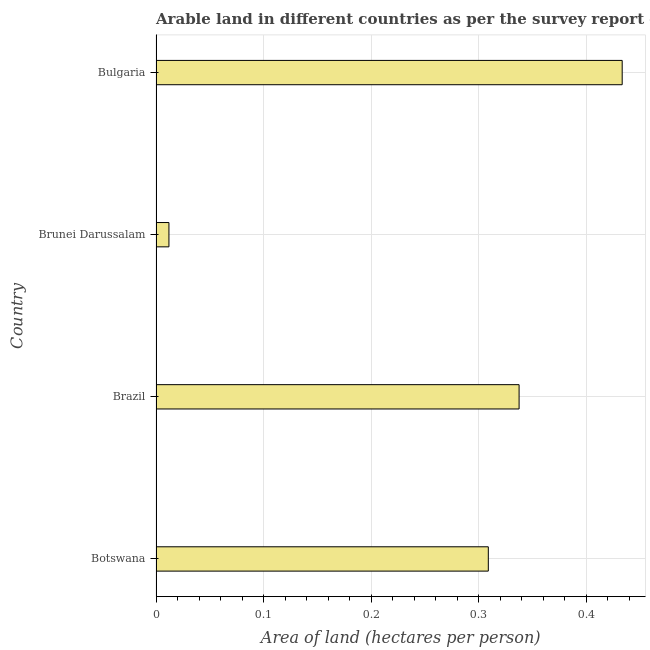What is the title of the graph?
Keep it short and to the point. Arable land in different countries as per the survey report of the year 1989. What is the label or title of the X-axis?
Offer a very short reply. Area of land (hectares per person). What is the label or title of the Y-axis?
Make the answer very short. Country. What is the area of arable land in Brunei Darussalam?
Offer a very short reply. 0.01. Across all countries, what is the maximum area of arable land?
Provide a succinct answer. 0.43. Across all countries, what is the minimum area of arable land?
Give a very brief answer. 0.01. In which country was the area of arable land maximum?
Your response must be concise. Bulgaria. In which country was the area of arable land minimum?
Provide a succinct answer. Brunei Darussalam. What is the sum of the area of arable land?
Your answer should be compact. 1.09. What is the difference between the area of arable land in Brazil and Brunei Darussalam?
Keep it short and to the point. 0.33. What is the average area of arable land per country?
Ensure brevity in your answer.  0.27. What is the median area of arable land?
Your answer should be very brief. 0.32. In how many countries, is the area of arable land greater than 0.02 hectares per person?
Your response must be concise. 3. What is the ratio of the area of arable land in Brazil to that in Brunei Darussalam?
Your answer should be very brief. 28.11. Is the difference between the area of arable land in Brazil and Bulgaria greater than the difference between any two countries?
Your answer should be compact. No. What is the difference between the highest and the second highest area of arable land?
Your response must be concise. 0.1. Is the sum of the area of arable land in Brazil and Bulgaria greater than the maximum area of arable land across all countries?
Keep it short and to the point. Yes. What is the difference between the highest and the lowest area of arable land?
Make the answer very short. 0.42. How many countries are there in the graph?
Offer a terse response. 4. Are the values on the major ticks of X-axis written in scientific E-notation?
Your answer should be compact. No. What is the Area of land (hectares per person) of Botswana?
Keep it short and to the point. 0.31. What is the Area of land (hectares per person) of Brazil?
Give a very brief answer. 0.34. What is the Area of land (hectares per person) in Brunei Darussalam?
Offer a terse response. 0.01. What is the Area of land (hectares per person) in Bulgaria?
Provide a succinct answer. 0.43. What is the difference between the Area of land (hectares per person) in Botswana and Brazil?
Give a very brief answer. -0.03. What is the difference between the Area of land (hectares per person) in Botswana and Brunei Darussalam?
Keep it short and to the point. 0.3. What is the difference between the Area of land (hectares per person) in Botswana and Bulgaria?
Offer a terse response. -0.12. What is the difference between the Area of land (hectares per person) in Brazil and Brunei Darussalam?
Your answer should be compact. 0.33. What is the difference between the Area of land (hectares per person) in Brazil and Bulgaria?
Make the answer very short. -0.1. What is the difference between the Area of land (hectares per person) in Brunei Darussalam and Bulgaria?
Give a very brief answer. -0.42. What is the ratio of the Area of land (hectares per person) in Botswana to that in Brazil?
Offer a terse response. 0.92. What is the ratio of the Area of land (hectares per person) in Botswana to that in Brunei Darussalam?
Offer a terse response. 25.72. What is the ratio of the Area of land (hectares per person) in Botswana to that in Bulgaria?
Ensure brevity in your answer.  0.71. What is the ratio of the Area of land (hectares per person) in Brazil to that in Brunei Darussalam?
Ensure brevity in your answer.  28.11. What is the ratio of the Area of land (hectares per person) in Brazil to that in Bulgaria?
Make the answer very short. 0.78. What is the ratio of the Area of land (hectares per person) in Brunei Darussalam to that in Bulgaria?
Your answer should be very brief. 0.03. 